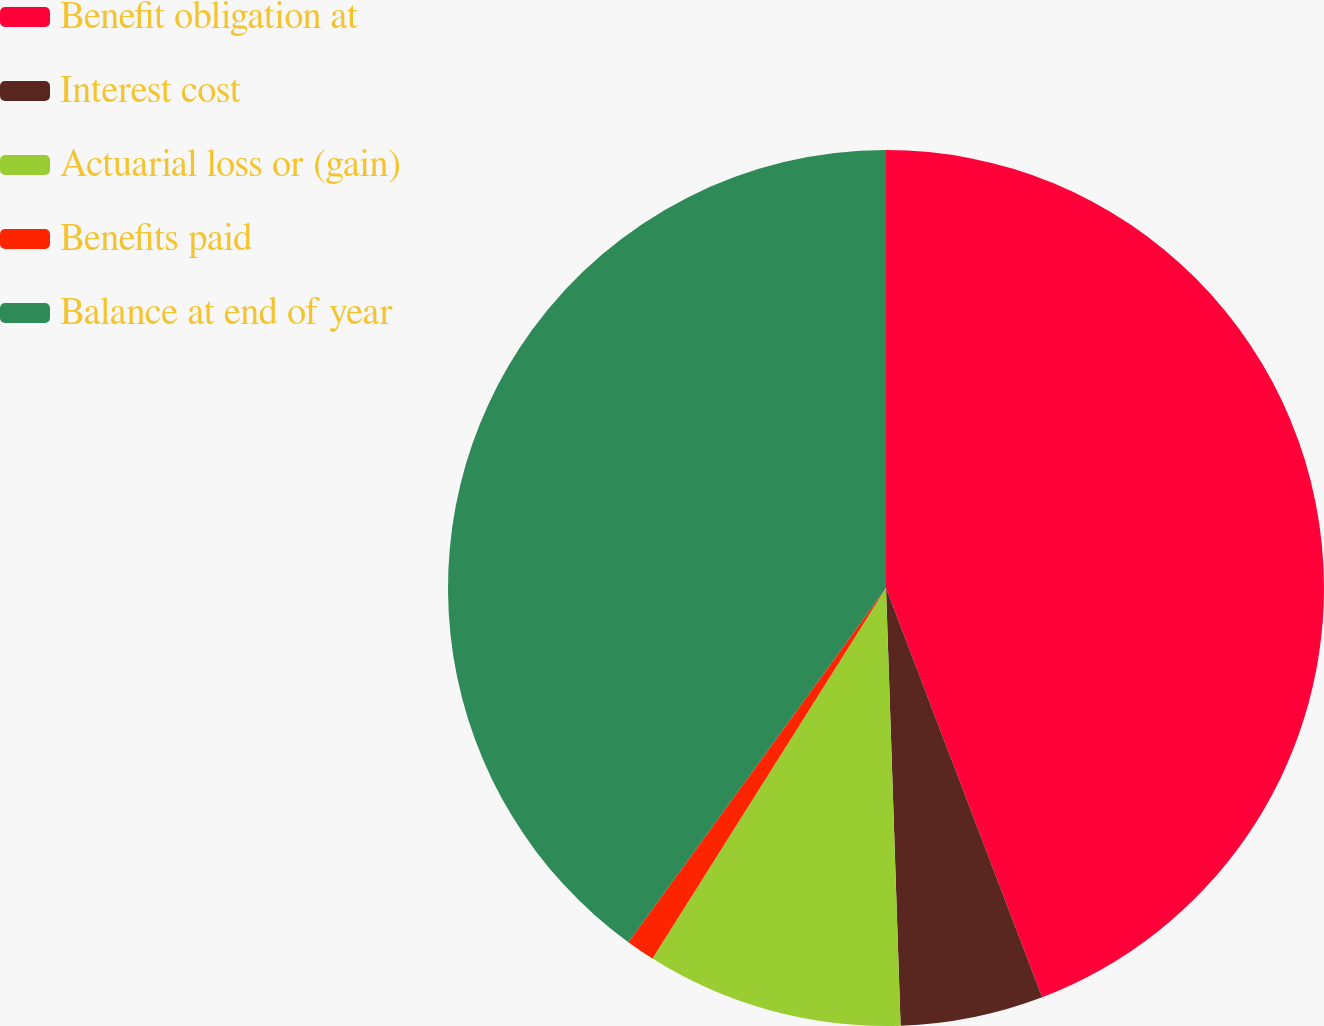<chart> <loc_0><loc_0><loc_500><loc_500><pie_chart><fcel>Benefit obligation at<fcel>Interest cost<fcel>Actuarial loss or (gain)<fcel>Benefits paid<fcel>Balance at end of year<nl><fcel>44.2%<fcel>5.27%<fcel>9.48%<fcel>1.06%<fcel>39.99%<nl></chart> 